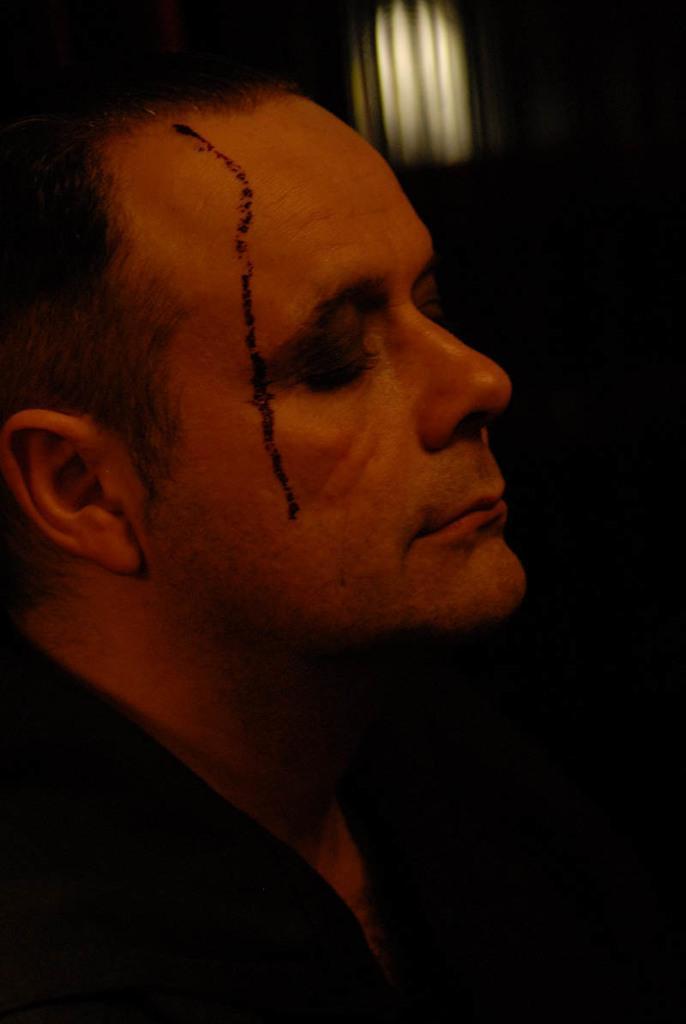Could you give a brief overview of what you see in this image? In this image I can see a man, he wore black color shirt. 